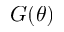<formula> <loc_0><loc_0><loc_500><loc_500>G ( \theta )</formula> 